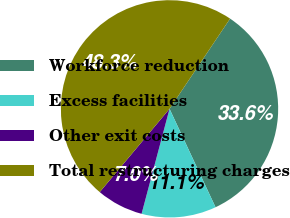Convert chart to OTSL. <chart><loc_0><loc_0><loc_500><loc_500><pie_chart><fcel>Workforce reduction<fcel>Excess facilities<fcel>Other exit costs<fcel>Total restructuring charges<nl><fcel>33.63%<fcel>11.1%<fcel>6.96%<fcel>48.31%<nl></chart> 